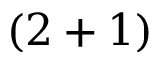<formula> <loc_0><loc_0><loc_500><loc_500>( 2 + 1 )</formula> 